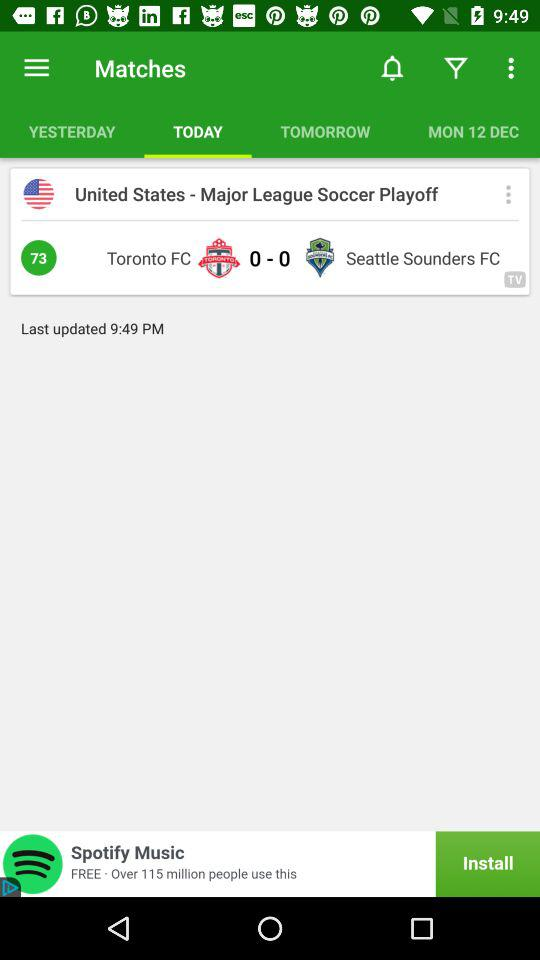How many goals were scored in this match?
Answer the question using a single word or phrase. 0 